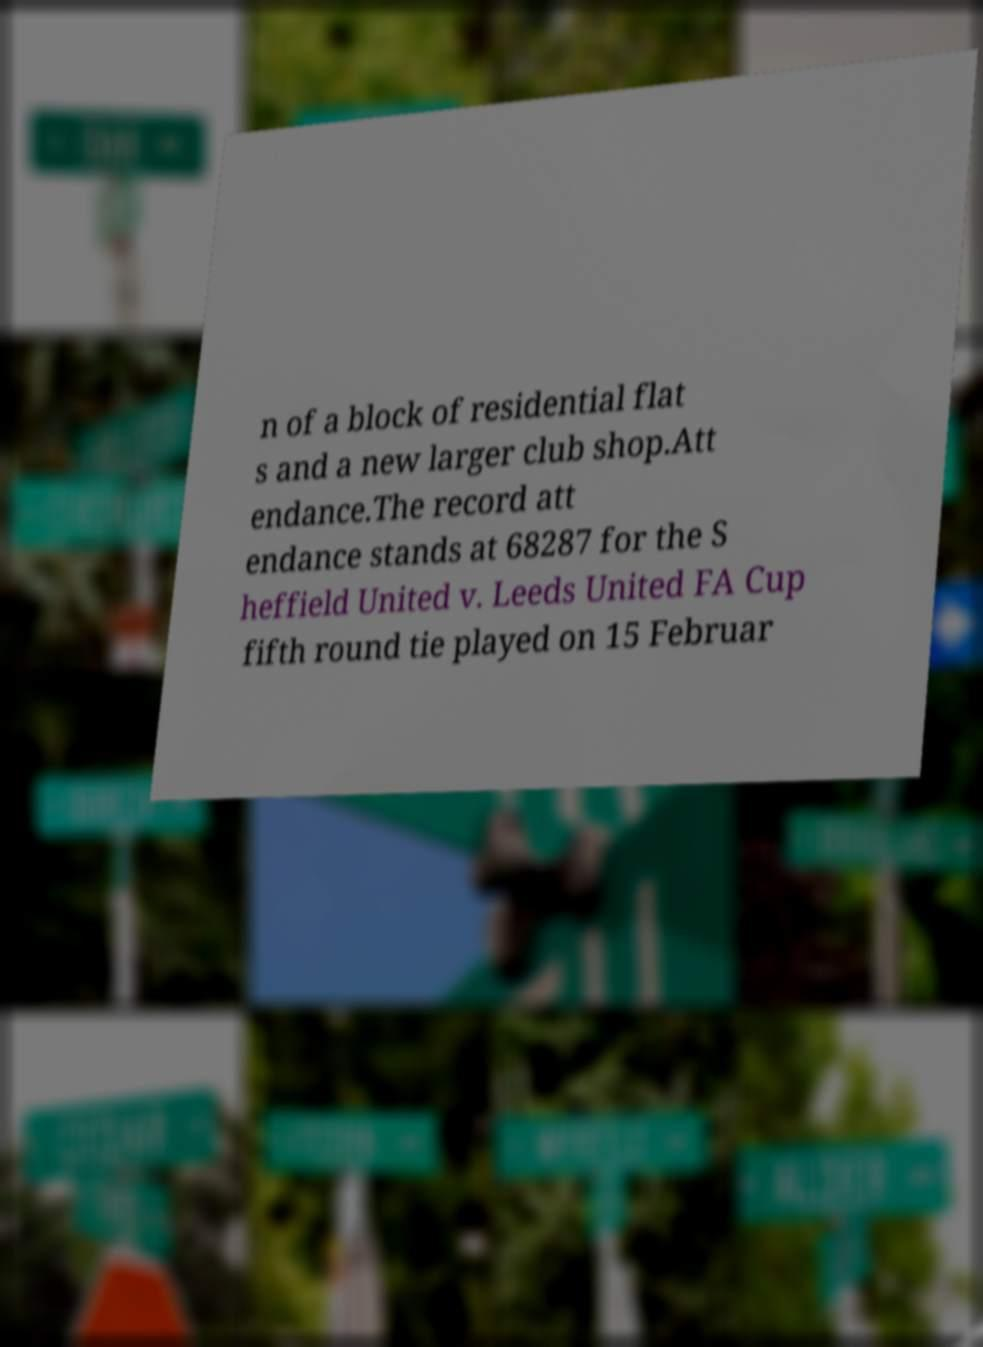Can you accurately transcribe the text from the provided image for me? n of a block of residential flat s and a new larger club shop.Att endance.The record att endance stands at 68287 for the S heffield United v. Leeds United FA Cup fifth round tie played on 15 Februar 